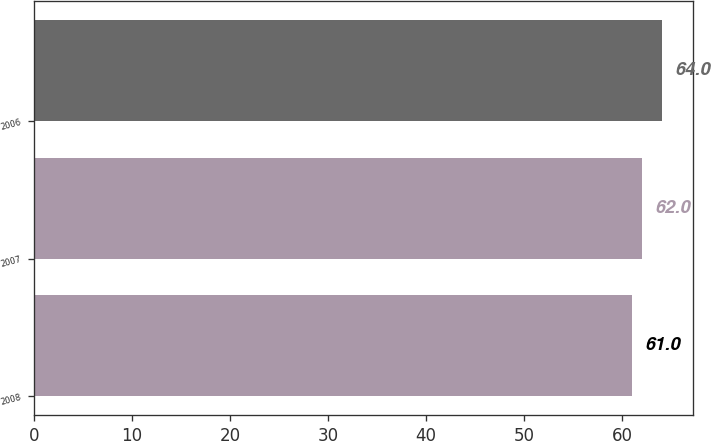Convert chart to OTSL. <chart><loc_0><loc_0><loc_500><loc_500><bar_chart><fcel>2008<fcel>2007<fcel>2006<nl><fcel>61<fcel>62<fcel>64<nl></chart> 